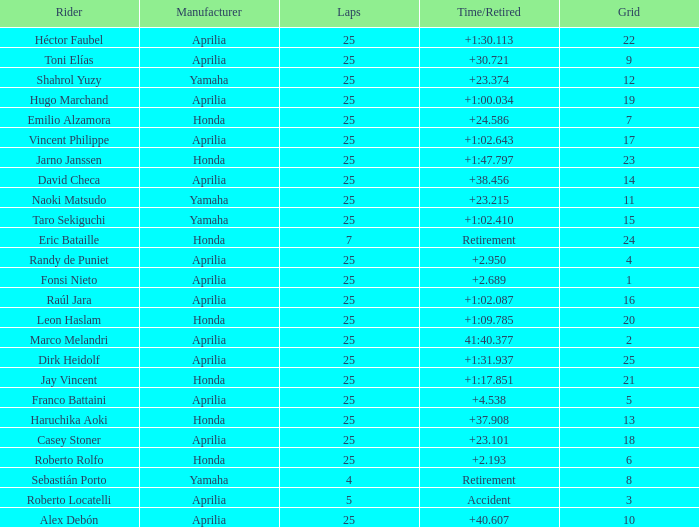Which Manufacturer has a Time/Retired of accident? Aprilia. 